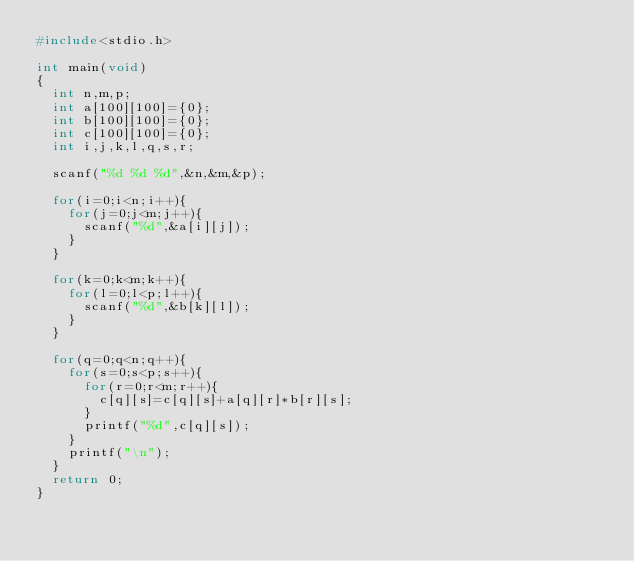<code> <loc_0><loc_0><loc_500><loc_500><_C_>#include<stdio.h>

int main(void)
{
	int n,m,p;
	int a[100][100]={0};
	int b[100][100]={0};	
	int c[100][100]={0};
	int i,j,k,l,q,s,r;

	scanf("%d %d %d",&n,&m,&p);	

	for(i=0;i<n;i++){
		for(j=0;j<m;j++){
			scanf("%d",&a[i][j]);
		}
	}
	
	for(k=0;k<m;k++){
		for(l=0;l<p;l++){
			scanf("%d",&b[k][l]);
		}
	}

	for(q=0;q<n;q++){
		for(s=0;s<p;s++){
			for(r=0;r<m;r++){
				c[q][s]=c[q][s]+a[q][r]*b[r][s];
			}
			printf("%d",c[q][s]);
		}
		printf("\n");
	}
	return 0;
}</code> 